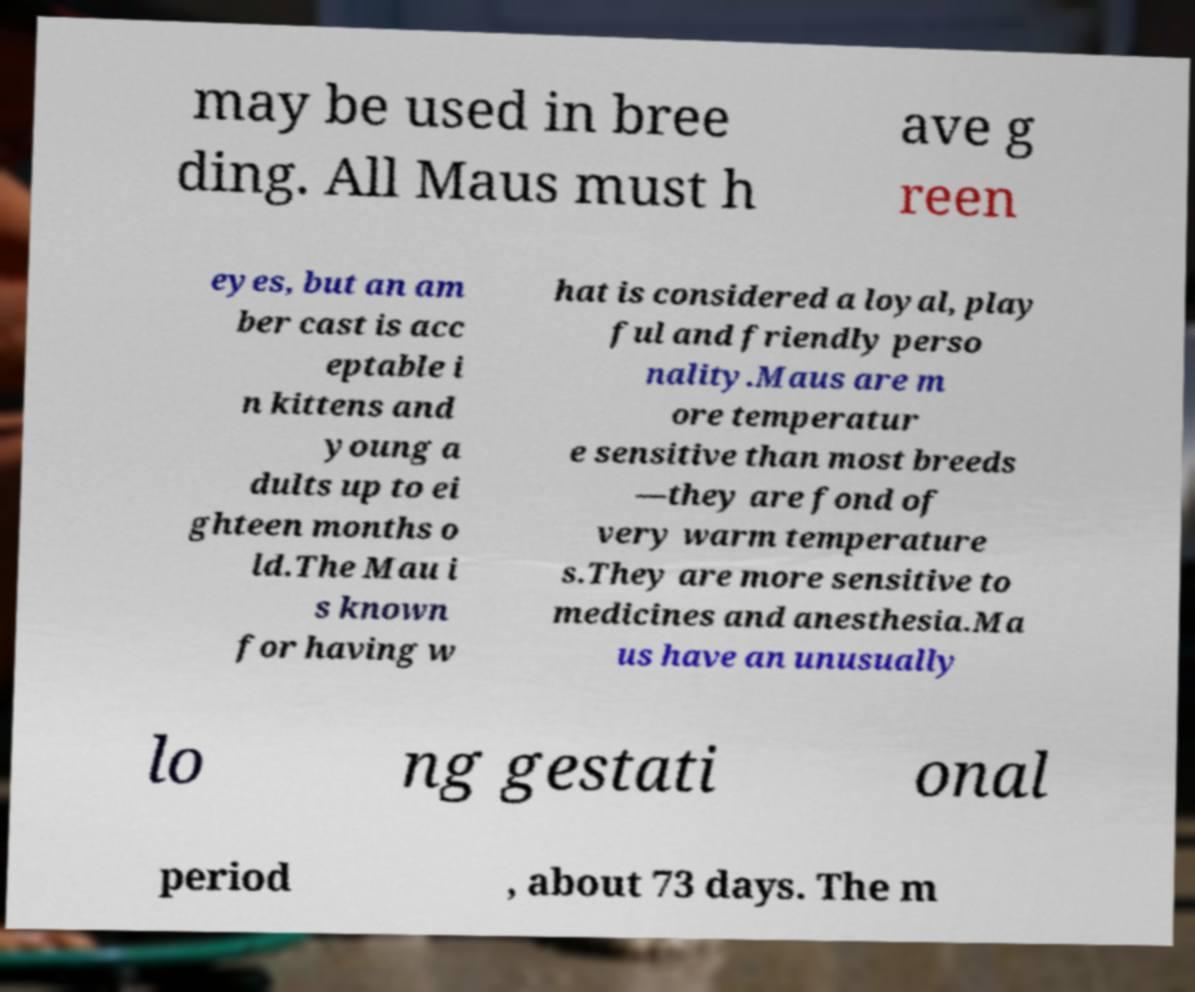Could you assist in decoding the text presented in this image and type it out clearly? may be used in bree ding. All Maus must h ave g reen eyes, but an am ber cast is acc eptable i n kittens and young a dults up to ei ghteen months o ld.The Mau i s known for having w hat is considered a loyal, play ful and friendly perso nality.Maus are m ore temperatur e sensitive than most breeds —they are fond of very warm temperature s.They are more sensitive to medicines and anesthesia.Ma us have an unusually lo ng gestati onal period , about 73 days. The m 